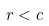Convert formula to latex. <formula><loc_0><loc_0><loc_500><loc_500>r < c</formula> 